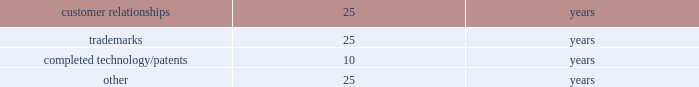Intangible assets such as patents , customer-related intangible assets and other intangible assets with finite useful lives are amortized on a straight-line basis over their estimated economic lives .
The weighted-average useful lives approximate the following: .
Recoverability of intangible assets with finite useful lives is assessed in the same manner as property , plant and equipment as described above .
Income taxes : for purposes of the company 2019s consolidated financial statements for periods prior to the spin-off , income tax expense has been recorded as if the company filed tax returns on a stand-alone basis separate from ingersoll rand .
This separate return methodology applies the accounting guidance for income taxes to the stand-alone financial statements as if the company was a stand-alone enterprise for the periods prior to the spin-off .
Therefore , cash tax payments and items of current and deferred taxes may not be reflective of the company 2019s actual tax balances prior to or subsequent to the spin-off .
Cash paid for income taxes , net of refunds for the twelve months ended december 31 , 2016 and 2015 was $ 10.4 million and $ 80.6 million , respectively .
The 2016 net cash income taxes paid includes a refund of $ 46.2 million received from the canadian tax authorities .
The income tax accounts reflected in the consolidated balance sheet as of december 31 , 2016 and 2015 include income taxes payable and deferred taxes allocated to the company at the time of the spin-off .
The calculation of the company 2019s income taxes involves considerable judgment and the use of both estimates and allocations .
Deferred tax assets and liabilities are determined based on temporary differences between financial reporting and tax bases of assets and liabilities , applying enacted tax rates expected to be in effect for the year in which the differences are expected to reverse .
The company recognizes future tax benefits , such as net operating losses and tax credits , to the extent that realizing these benefits is considered in its judgment to be more likely than not .
The company regularly reviews the recoverability of its deferred tax assets considering its historic profitability , projected future taxable income , timing of the reversals of existing temporary differences and the feasibility of its tax planning strategies .
Where appropriate , the company records a valuation allowance with respect to a future tax benefit .
Product warranties : standard product warranty accruals are recorded at the time of sale and are estimated based upon product warranty terms and historical experience .
The company assesses the adequacy of its liabilities and will make adjustments as necessary based on known or anticipated warranty claims , or as new information becomes available .
Revenue recognition : revenue is recognized and earned when all of the following criteria are satisfied : ( a ) persuasive evidence of a sales arrangement exists ; ( b ) the price is fixed or determinable ; ( c ) collectability is reasonably assured ; and ( d ) delivery has occurred or service has been rendered .
Delivery generally occurs when the title and the risks and rewards of ownership have transferred to the customer .
Both the persuasive evidence of a sales arrangement and fixed or determinable price criteria are deemed to be satisfied upon receipt of an executed and legally binding sales agreement or contract that clearly defines the terms and conditions of the transaction including the respective obligations of the parties .
If the defined terms and conditions allow variability in all or a component of the price , revenue is not recognized until such time that the price becomes fixed or determinable .
At the point of sale , the company validates the existence of an enforceable claim that requires payment within a reasonable amount of time and assesses the collectability of that claim .
If collectability is not deemed to be reasonably assured , then revenue recognition is deferred until such time that collectability becomes probable or cash is received .
Delivery is not considered to have occurred until the customer has taken title and assumed the risks and rewards of ownership .
Service and installation revenue are recognized when earned .
In some instances , customer acceptance provisions are included in sales arrangements to give the buyer the ability to ensure the delivered product or service meets the criteria established in the order .
In these instances , revenue recognition is deferred until the acceptance terms specified in the arrangement are fulfilled through customer acceptance or a demonstration that established criteria have been satisfied .
If uncertainty exists about customer acceptance , revenue is not recognized until acceptance has occurred .
The company offers various sales incentive programs to our customers , dealers , and distributors .
Sales incentive programs do not preclude revenue recognition , but do require an accrual for the company 2019s best estimate of expected activity .
Examples of the sales incentives that are accrued for as a contra receivable and sales deduction at the point of sale include , but are not limited to , discounts ( i.e .
Net 30 type ) , coupons , and rebates where the customer does not have to provide any additional requirements to receive the discount .
Sales returns and customer disputes involving a question of quantity or price are also accounted for as a .
Considering the years 2015-2016 , what was the average cash paid for income taxes? 
Rationale: it is the sum of the cash paid during these years divided by two .
Computations: ((10.4 + 80.6) / 2)
Answer: 45.5. 